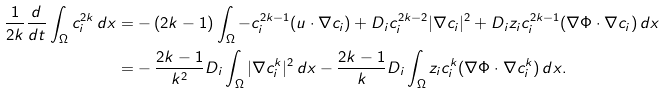Convert formula to latex. <formula><loc_0><loc_0><loc_500><loc_500>\frac { 1 } { 2 k } \frac { d } { d t } \int _ { \Omega } c _ { i } ^ { 2 k } \, d x = & - ( 2 k - 1 ) \int _ { \Omega } - c _ { i } ^ { 2 k - 1 } ( u \cdot \nabla c _ { i } ) + D _ { i } c _ { i } ^ { 2 k - 2 } | \nabla c _ { i } | ^ { 2 } + D _ { i } z _ { i } c _ { i } ^ { 2 k - 1 } ( \nabla \Phi \cdot \nabla c _ { i } ) \, d x \\ = & - \frac { 2 k - 1 } { k ^ { 2 } } D _ { i } \int _ { \Omega } | \nabla c _ { i } ^ { k } | ^ { 2 } \, d x - \frac { 2 k - 1 } { k } D _ { i } \int _ { \Omega } z _ { i } c _ { i } ^ { k } ( \nabla \Phi \cdot \nabla c _ { i } ^ { k } ) \, d x .</formula> 